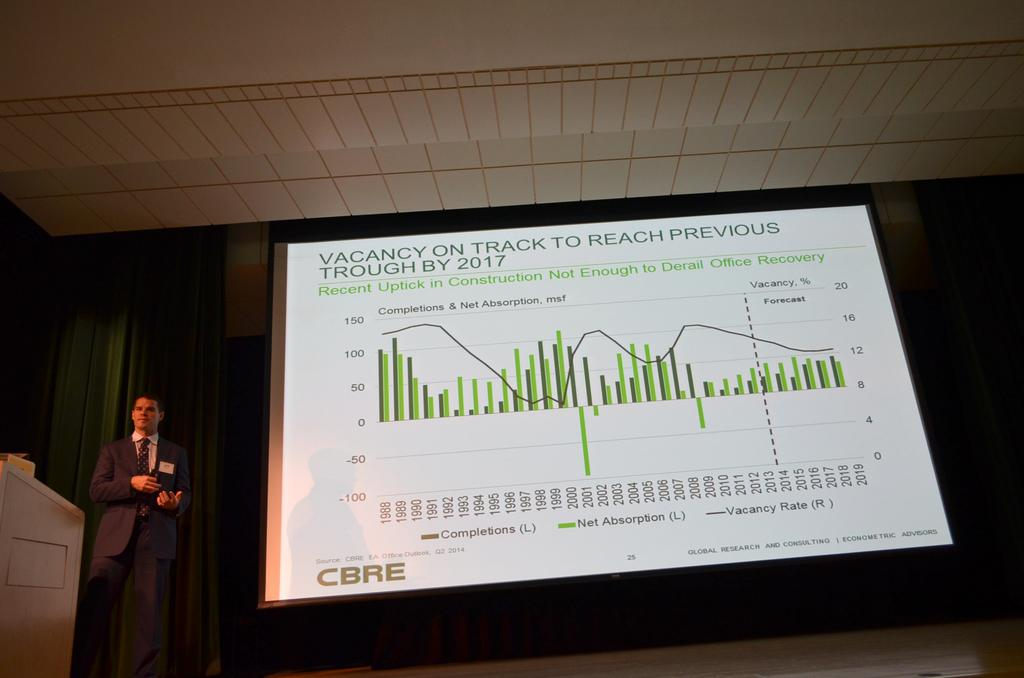What is located on the left side of the image? There is a man on the left side of the image. What is the man doing in the image? The man is standing in the image. What is beside the man in the image? There is a projector screen beside the man. What can be seen in the background of the image? There are curtains in the background of the image. How many ladybugs can be seen on the man's shoulder in the image? There are no ladybugs visible on the man's shoulder in the image. What type of quiver is the man holding in the image? The man is not holding any quiver in the image. 